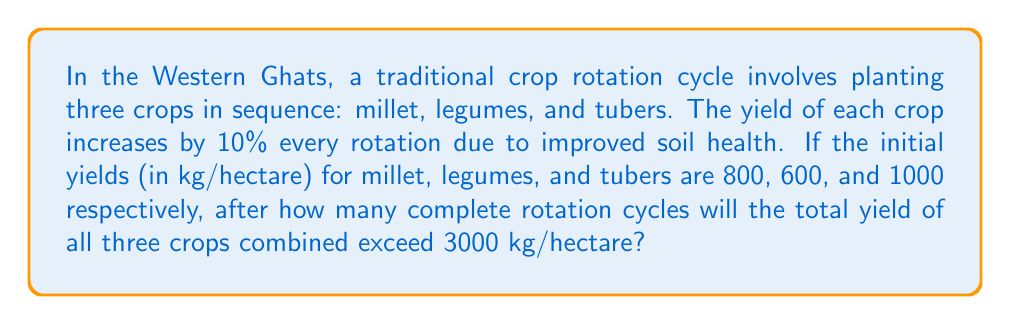Show me your answer to this math problem. Let's approach this step-by-step:

1) First, we need to set up arithmetic sequences for each crop's yield:

   Millet: $a_n = 800(1.1)^{n-1}$
   Legumes: $b_n = 600(1.1)^{n-1}$
   Tubers: $c_n = 1000(1.1)^{n-1}$

   Where $n$ is the number of rotation cycles.

2) The total yield after $n$ cycles is the sum of these three sequences:

   $T_n = 800(1.1)^{n-1} + 600(1.1)^{n-1} + 1000(1.1)^{n-1}$

3) We can factor out the common term:

   $T_n = (800 + 600 + 1000)(1.1)^{n-1} = 2400(1.1)^{n-1}$

4) We want to find $n$ where $T_n > 3000$:

   $2400(1.1)^{n-1} > 3000$

5) Divide both sides by 2400:

   $(1.1)^{n-1} > 1.25$

6) Take the natural log of both sides:

   $(n-1)\ln(1.1) > \ln(1.25)$

7) Solve for $n$:

   $n > \frac{\ln(1.25)}{\ln(1.1)} + 1 \approx 3.32$

8) Since $n$ must be a whole number (complete rotation cycles), we round up to the next integer.
Answer: 4 rotation cycles 